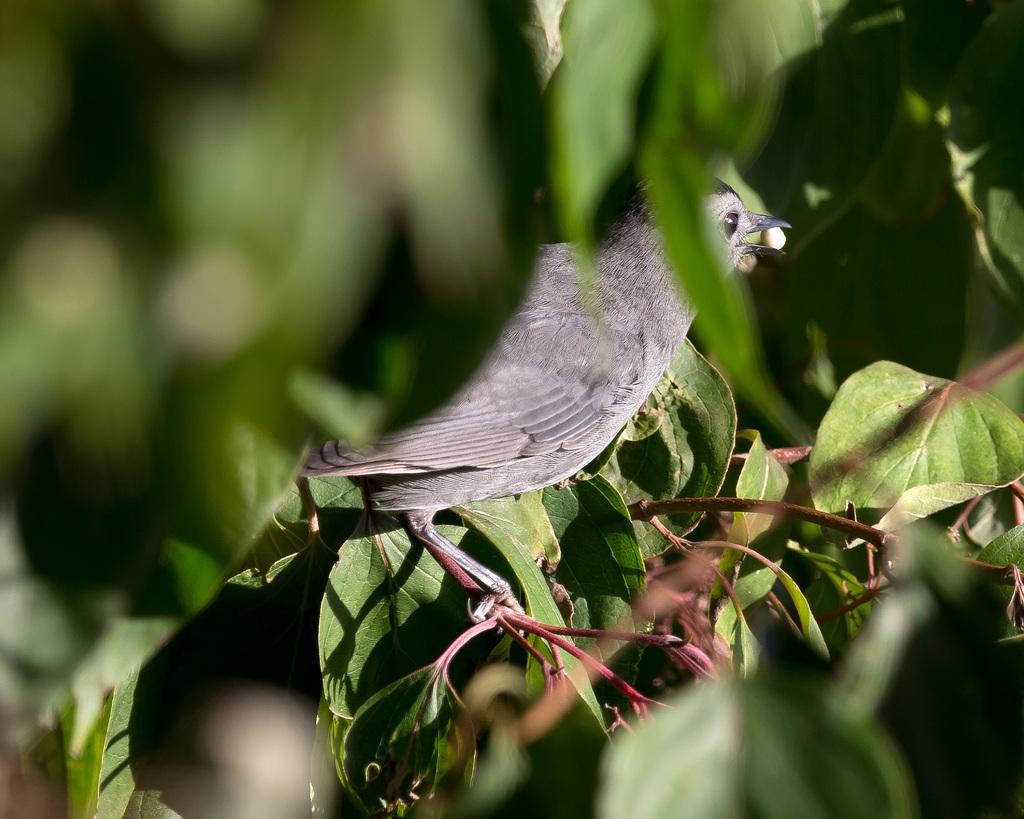Describe this image in one or two sentences. In the image we can see a bird, gray in color and the bird is sitting on the stem. Here we can see leaves. 